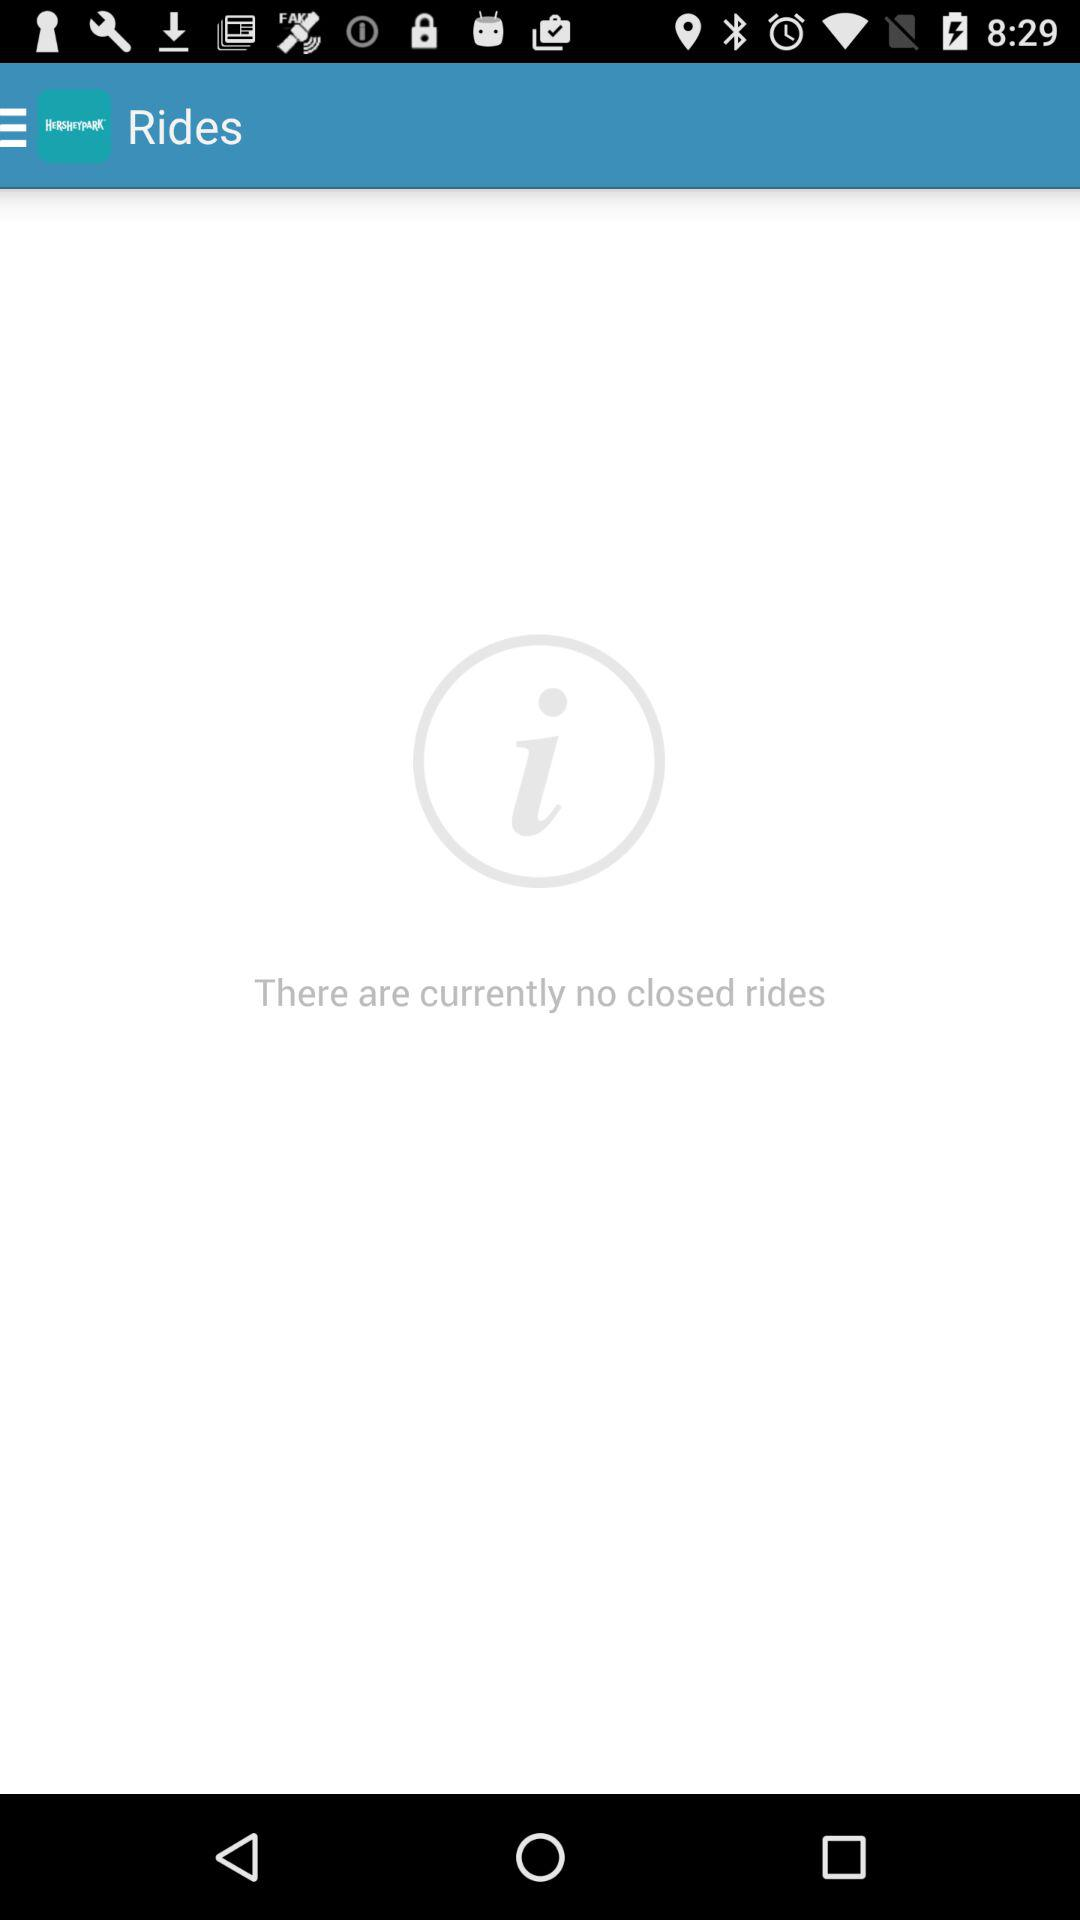If all of the closed rides were opened, how many closed rides would there be?
Answer the question using a single word or phrase. 0 